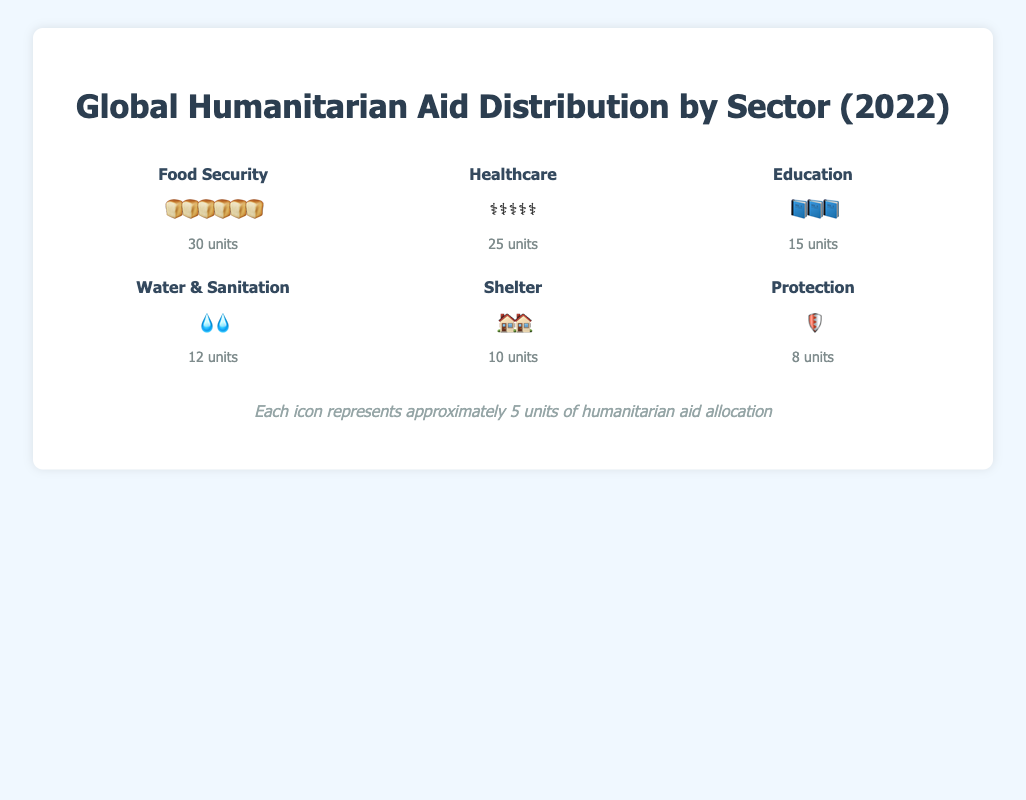What sector received the most humanitarian aid units? The figure shows that Food Security received the most units. The Food Security sector has 30 bread icons, which are the most numerous compared to the other sectors.
Answer: Food Security Which sectors received less aid than Healthcare? Healthcare received 25 units. Sectors that received less than 25 units are Education (15 units), Water & Sanitation (12 units), Shelter (10 units), and Protection (8 units).
Answer: Education, Water & Sanitation, Shelter, Protection How many sectors received more than 10 units of aid? To find this, we count the sectors where the units are greater than 10. These sectors are Food Security (30), Healthcare (25), and Education (15).
Answer: 3 What is the total number of units allocated to the Education and Shelter sectors combined? Education has 15 units, and Shelter has 10 units. Adding these together gives 15 + 10 = 25 units.
Answer: 25 units Which sector has the least amount of aid, and how many units did it receive? The sector with the least amount of aid is Protection. It has 8 shield icons, indicating it received 8 units.
Answer: Protection, 8 units How many units more of aid did Food Security receive compared to Shelter? Food Security received 30 units, and Shelter received 10 units. The difference is 30 - 10 = 20 units.
Answer: 20 units What percentage of the total aid units is allocated to Healthcare? Healthcare received 25 units out of a total of 100 units. The percentage is (25/100) * 100 = 25%.
Answer: 25% Order the sectors from the one with the highest aid to the lowest. The sectors ordered from highest to lowest based on the units are: Food Security (30), Healthcare (25), Education (15), Water & Sanitation (12), Shelter (10), Protection (8).
Answer: Food Security, Healthcare, Education, Water & Sanitation, Shelter, Protection If each icon represents approximately 5 units of aid, how many icons should there be for the Water & Sanitation sector? Water & Sanitation has 12 units. Each icon represents approximately 5 units, so 12/5 ≈ 2.4. Therefore, the number of icons is roughly 2-3.
Answer: 2-3 icons 